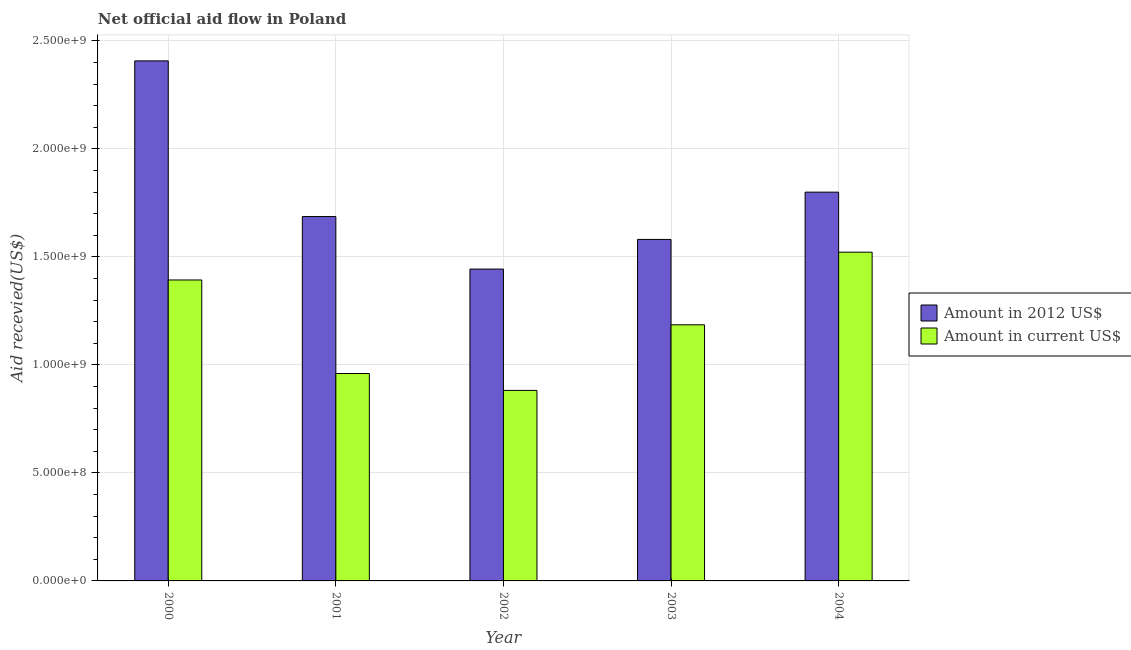How many different coloured bars are there?
Offer a very short reply. 2. How many groups of bars are there?
Offer a very short reply. 5. Are the number of bars per tick equal to the number of legend labels?
Offer a terse response. Yes. Are the number of bars on each tick of the X-axis equal?
Keep it short and to the point. Yes. What is the amount of aid received(expressed in us$) in 2001?
Your answer should be very brief. 9.60e+08. Across all years, what is the maximum amount of aid received(expressed in us$)?
Give a very brief answer. 1.52e+09. Across all years, what is the minimum amount of aid received(expressed in us$)?
Ensure brevity in your answer.  8.82e+08. In which year was the amount of aid received(expressed in us$) minimum?
Offer a very short reply. 2002. What is the total amount of aid received(expressed in us$) in the graph?
Your answer should be very brief. 5.94e+09. What is the difference between the amount of aid received(expressed in 2012 us$) in 2000 and that in 2002?
Ensure brevity in your answer.  9.64e+08. What is the difference between the amount of aid received(expressed in us$) in 2000 and the amount of aid received(expressed in 2012 us$) in 2002?
Ensure brevity in your answer.  5.11e+08. What is the average amount of aid received(expressed in 2012 us$) per year?
Your answer should be compact. 1.78e+09. In how many years, is the amount of aid received(expressed in us$) greater than 1200000000 US$?
Provide a succinct answer. 2. What is the ratio of the amount of aid received(expressed in 2012 us$) in 2000 to that in 2002?
Provide a short and direct response. 1.67. Is the amount of aid received(expressed in us$) in 2001 less than that in 2002?
Your answer should be compact. No. Is the difference between the amount of aid received(expressed in us$) in 2001 and 2002 greater than the difference between the amount of aid received(expressed in 2012 us$) in 2001 and 2002?
Provide a succinct answer. No. What is the difference between the highest and the second highest amount of aid received(expressed in 2012 us$)?
Your response must be concise. 6.08e+08. What is the difference between the highest and the lowest amount of aid received(expressed in 2012 us$)?
Provide a succinct answer. 9.64e+08. What does the 2nd bar from the left in 2002 represents?
Keep it short and to the point. Amount in current US$. What does the 1st bar from the right in 2000 represents?
Your answer should be very brief. Amount in current US$. How many bars are there?
Provide a succinct answer. 10. Are all the bars in the graph horizontal?
Provide a short and direct response. No. How many years are there in the graph?
Your answer should be very brief. 5. What is the difference between two consecutive major ticks on the Y-axis?
Offer a very short reply. 5.00e+08. Are the values on the major ticks of Y-axis written in scientific E-notation?
Your answer should be very brief. Yes. Does the graph contain any zero values?
Make the answer very short. No. Does the graph contain grids?
Provide a succinct answer. Yes. Where does the legend appear in the graph?
Your response must be concise. Center right. What is the title of the graph?
Your response must be concise. Net official aid flow in Poland. Does "Excluding technical cooperation" appear as one of the legend labels in the graph?
Keep it short and to the point. No. What is the label or title of the X-axis?
Your response must be concise. Year. What is the label or title of the Y-axis?
Provide a short and direct response. Aid recevied(US$). What is the Aid recevied(US$) of Amount in 2012 US$ in 2000?
Your response must be concise. 2.41e+09. What is the Aid recevied(US$) in Amount in current US$ in 2000?
Provide a short and direct response. 1.39e+09. What is the Aid recevied(US$) in Amount in 2012 US$ in 2001?
Provide a succinct answer. 1.69e+09. What is the Aid recevied(US$) in Amount in current US$ in 2001?
Keep it short and to the point. 9.60e+08. What is the Aid recevied(US$) in Amount in 2012 US$ in 2002?
Offer a terse response. 1.44e+09. What is the Aid recevied(US$) of Amount in current US$ in 2002?
Make the answer very short. 8.82e+08. What is the Aid recevied(US$) in Amount in 2012 US$ in 2003?
Provide a short and direct response. 1.58e+09. What is the Aid recevied(US$) in Amount in current US$ in 2003?
Ensure brevity in your answer.  1.19e+09. What is the Aid recevied(US$) in Amount in 2012 US$ in 2004?
Offer a terse response. 1.80e+09. What is the Aid recevied(US$) of Amount in current US$ in 2004?
Your answer should be very brief. 1.52e+09. Across all years, what is the maximum Aid recevied(US$) of Amount in 2012 US$?
Make the answer very short. 2.41e+09. Across all years, what is the maximum Aid recevied(US$) of Amount in current US$?
Offer a very short reply. 1.52e+09. Across all years, what is the minimum Aid recevied(US$) of Amount in 2012 US$?
Ensure brevity in your answer.  1.44e+09. Across all years, what is the minimum Aid recevied(US$) in Amount in current US$?
Your answer should be compact. 8.82e+08. What is the total Aid recevied(US$) of Amount in 2012 US$ in the graph?
Offer a terse response. 8.92e+09. What is the total Aid recevied(US$) in Amount in current US$ in the graph?
Your answer should be very brief. 5.94e+09. What is the difference between the Aid recevied(US$) of Amount in 2012 US$ in 2000 and that in 2001?
Your response must be concise. 7.21e+08. What is the difference between the Aid recevied(US$) of Amount in current US$ in 2000 and that in 2001?
Provide a short and direct response. 4.33e+08. What is the difference between the Aid recevied(US$) of Amount in 2012 US$ in 2000 and that in 2002?
Your response must be concise. 9.64e+08. What is the difference between the Aid recevied(US$) of Amount in current US$ in 2000 and that in 2002?
Provide a succinct answer. 5.11e+08. What is the difference between the Aid recevied(US$) in Amount in 2012 US$ in 2000 and that in 2003?
Ensure brevity in your answer.  8.27e+08. What is the difference between the Aid recevied(US$) of Amount in current US$ in 2000 and that in 2003?
Your answer should be compact. 2.08e+08. What is the difference between the Aid recevied(US$) in Amount in 2012 US$ in 2000 and that in 2004?
Give a very brief answer. 6.08e+08. What is the difference between the Aid recevied(US$) of Amount in current US$ in 2000 and that in 2004?
Provide a short and direct response. -1.29e+08. What is the difference between the Aid recevied(US$) in Amount in 2012 US$ in 2001 and that in 2002?
Your answer should be very brief. 2.43e+08. What is the difference between the Aid recevied(US$) of Amount in current US$ in 2001 and that in 2002?
Offer a terse response. 7.83e+07. What is the difference between the Aid recevied(US$) of Amount in 2012 US$ in 2001 and that in 2003?
Provide a succinct answer. 1.06e+08. What is the difference between the Aid recevied(US$) of Amount in current US$ in 2001 and that in 2003?
Give a very brief answer. -2.25e+08. What is the difference between the Aid recevied(US$) of Amount in 2012 US$ in 2001 and that in 2004?
Provide a short and direct response. -1.13e+08. What is the difference between the Aid recevied(US$) of Amount in current US$ in 2001 and that in 2004?
Your answer should be compact. -5.62e+08. What is the difference between the Aid recevied(US$) of Amount in 2012 US$ in 2002 and that in 2003?
Make the answer very short. -1.37e+08. What is the difference between the Aid recevied(US$) of Amount in current US$ in 2002 and that in 2003?
Make the answer very short. -3.04e+08. What is the difference between the Aid recevied(US$) of Amount in 2012 US$ in 2002 and that in 2004?
Offer a very short reply. -3.56e+08. What is the difference between the Aid recevied(US$) in Amount in current US$ in 2002 and that in 2004?
Provide a succinct answer. -6.40e+08. What is the difference between the Aid recevied(US$) in Amount in 2012 US$ in 2003 and that in 2004?
Keep it short and to the point. -2.19e+08. What is the difference between the Aid recevied(US$) of Amount in current US$ in 2003 and that in 2004?
Provide a succinct answer. -3.36e+08. What is the difference between the Aid recevied(US$) in Amount in 2012 US$ in 2000 and the Aid recevied(US$) in Amount in current US$ in 2001?
Offer a very short reply. 1.45e+09. What is the difference between the Aid recevied(US$) in Amount in 2012 US$ in 2000 and the Aid recevied(US$) in Amount in current US$ in 2002?
Make the answer very short. 1.53e+09. What is the difference between the Aid recevied(US$) of Amount in 2012 US$ in 2000 and the Aid recevied(US$) of Amount in current US$ in 2003?
Your answer should be very brief. 1.22e+09. What is the difference between the Aid recevied(US$) of Amount in 2012 US$ in 2000 and the Aid recevied(US$) of Amount in current US$ in 2004?
Provide a short and direct response. 8.86e+08. What is the difference between the Aid recevied(US$) of Amount in 2012 US$ in 2001 and the Aid recevied(US$) of Amount in current US$ in 2002?
Provide a short and direct response. 8.05e+08. What is the difference between the Aid recevied(US$) of Amount in 2012 US$ in 2001 and the Aid recevied(US$) of Amount in current US$ in 2003?
Keep it short and to the point. 5.01e+08. What is the difference between the Aid recevied(US$) of Amount in 2012 US$ in 2001 and the Aid recevied(US$) of Amount in current US$ in 2004?
Make the answer very short. 1.65e+08. What is the difference between the Aid recevied(US$) of Amount in 2012 US$ in 2002 and the Aid recevied(US$) of Amount in current US$ in 2003?
Your response must be concise. 2.58e+08. What is the difference between the Aid recevied(US$) in Amount in 2012 US$ in 2002 and the Aid recevied(US$) in Amount in current US$ in 2004?
Provide a succinct answer. -7.82e+07. What is the difference between the Aid recevied(US$) in Amount in 2012 US$ in 2003 and the Aid recevied(US$) in Amount in current US$ in 2004?
Offer a very short reply. 5.90e+07. What is the average Aid recevied(US$) of Amount in 2012 US$ per year?
Ensure brevity in your answer.  1.78e+09. What is the average Aid recevied(US$) in Amount in current US$ per year?
Keep it short and to the point. 1.19e+09. In the year 2000, what is the difference between the Aid recevied(US$) in Amount in 2012 US$ and Aid recevied(US$) in Amount in current US$?
Give a very brief answer. 1.01e+09. In the year 2001, what is the difference between the Aid recevied(US$) of Amount in 2012 US$ and Aid recevied(US$) of Amount in current US$?
Give a very brief answer. 7.27e+08. In the year 2002, what is the difference between the Aid recevied(US$) of Amount in 2012 US$ and Aid recevied(US$) of Amount in current US$?
Ensure brevity in your answer.  5.62e+08. In the year 2003, what is the difference between the Aid recevied(US$) of Amount in 2012 US$ and Aid recevied(US$) of Amount in current US$?
Ensure brevity in your answer.  3.95e+08. In the year 2004, what is the difference between the Aid recevied(US$) in Amount in 2012 US$ and Aid recevied(US$) in Amount in current US$?
Offer a very short reply. 2.78e+08. What is the ratio of the Aid recevied(US$) in Amount in 2012 US$ in 2000 to that in 2001?
Give a very brief answer. 1.43. What is the ratio of the Aid recevied(US$) in Amount in current US$ in 2000 to that in 2001?
Provide a succinct answer. 1.45. What is the ratio of the Aid recevied(US$) in Amount in 2012 US$ in 2000 to that in 2002?
Your response must be concise. 1.67. What is the ratio of the Aid recevied(US$) of Amount in current US$ in 2000 to that in 2002?
Make the answer very short. 1.58. What is the ratio of the Aid recevied(US$) of Amount in 2012 US$ in 2000 to that in 2003?
Offer a very short reply. 1.52. What is the ratio of the Aid recevied(US$) in Amount in current US$ in 2000 to that in 2003?
Offer a terse response. 1.18. What is the ratio of the Aid recevied(US$) of Amount in 2012 US$ in 2000 to that in 2004?
Your response must be concise. 1.34. What is the ratio of the Aid recevied(US$) of Amount in current US$ in 2000 to that in 2004?
Ensure brevity in your answer.  0.92. What is the ratio of the Aid recevied(US$) of Amount in 2012 US$ in 2001 to that in 2002?
Provide a short and direct response. 1.17. What is the ratio of the Aid recevied(US$) of Amount in current US$ in 2001 to that in 2002?
Ensure brevity in your answer.  1.09. What is the ratio of the Aid recevied(US$) in Amount in 2012 US$ in 2001 to that in 2003?
Your answer should be very brief. 1.07. What is the ratio of the Aid recevied(US$) in Amount in current US$ in 2001 to that in 2003?
Keep it short and to the point. 0.81. What is the ratio of the Aid recevied(US$) in Amount in 2012 US$ in 2001 to that in 2004?
Ensure brevity in your answer.  0.94. What is the ratio of the Aid recevied(US$) in Amount in current US$ in 2001 to that in 2004?
Give a very brief answer. 0.63. What is the ratio of the Aid recevied(US$) of Amount in 2012 US$ in 2002 to that in 2003?
Keep it short and to the point. 0.91. What is the ratio of the Aid recevied(US$) of Amount in current US$ in 2002 to that in 2003?
Your response must be concise. 0.74. What is the ratio of the Aid recevied(US$) in Amount in 2012 US$ in 2002 to that in 2004?
Make the answer very short. 0.8. What is the ratio of the Aid recevied(US$) of Amount in current US$ in 2002 to that in 2004?
Provide a short and direct response. 0.58. What is the ratio of the Aid recevied(US$) in Amount in 2012 US$ in 2003 to that in 2004?
Make the answer very short. 0.88. What is the ratio of the Aid recevied(US$) in Amount in current US$ in 2003 to that in 2004?
Offer a terse response. 0.78. What is the difference between the highest and the second highest Aid recevied(US$) of Amount in 2012 US$?
Provide a succinct answer. 6.08e+08. What is the difference between the highest and the second highest Aid recevied(US$) in Amount in current US$?
Keep it short and to the point. 1.29e+08. What is the difference between the highest and the lowest Aid recevied(US$) of Amount in 2012 US$?
Your answer should be compact. 9.64e+08. What is the difference between the highest and the lowest Aid recevied(US$) in Amount in current US$?
Offer a very short reply. 6.40e+08. 